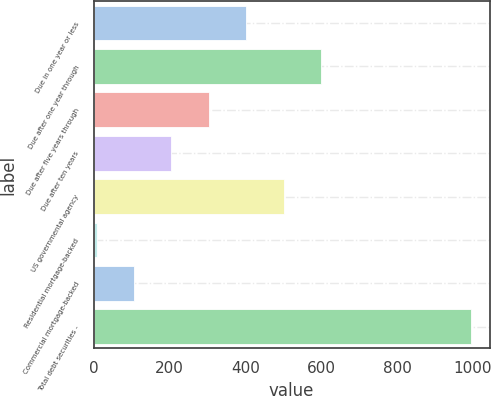<chart> <loc_0><loc_0><loc_500><loc_500><bar_chart><fcel>Due in one year or less<fcel>Due after one year through<fcel>Due after five years through<fcel>Due after ten years<fcel>US governmental agency<fcel>Residential mortgage-backed<fcel>Commercial mortgage-backed<fcel>Total debt securities -<nl><fcel>402.4<fcel>599.6<fcel>303.8<fcel>205.2<fcel>501<fcel>8<fcel>106.6<fcel>994<nl></chart> 